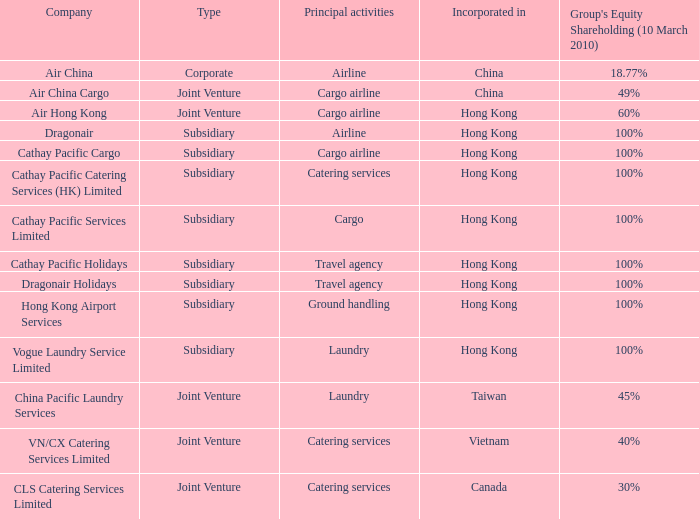Which company has a group equity shareholding percentage, as of March 10th 2010 of 30%? CLS Catering Services Limited. 